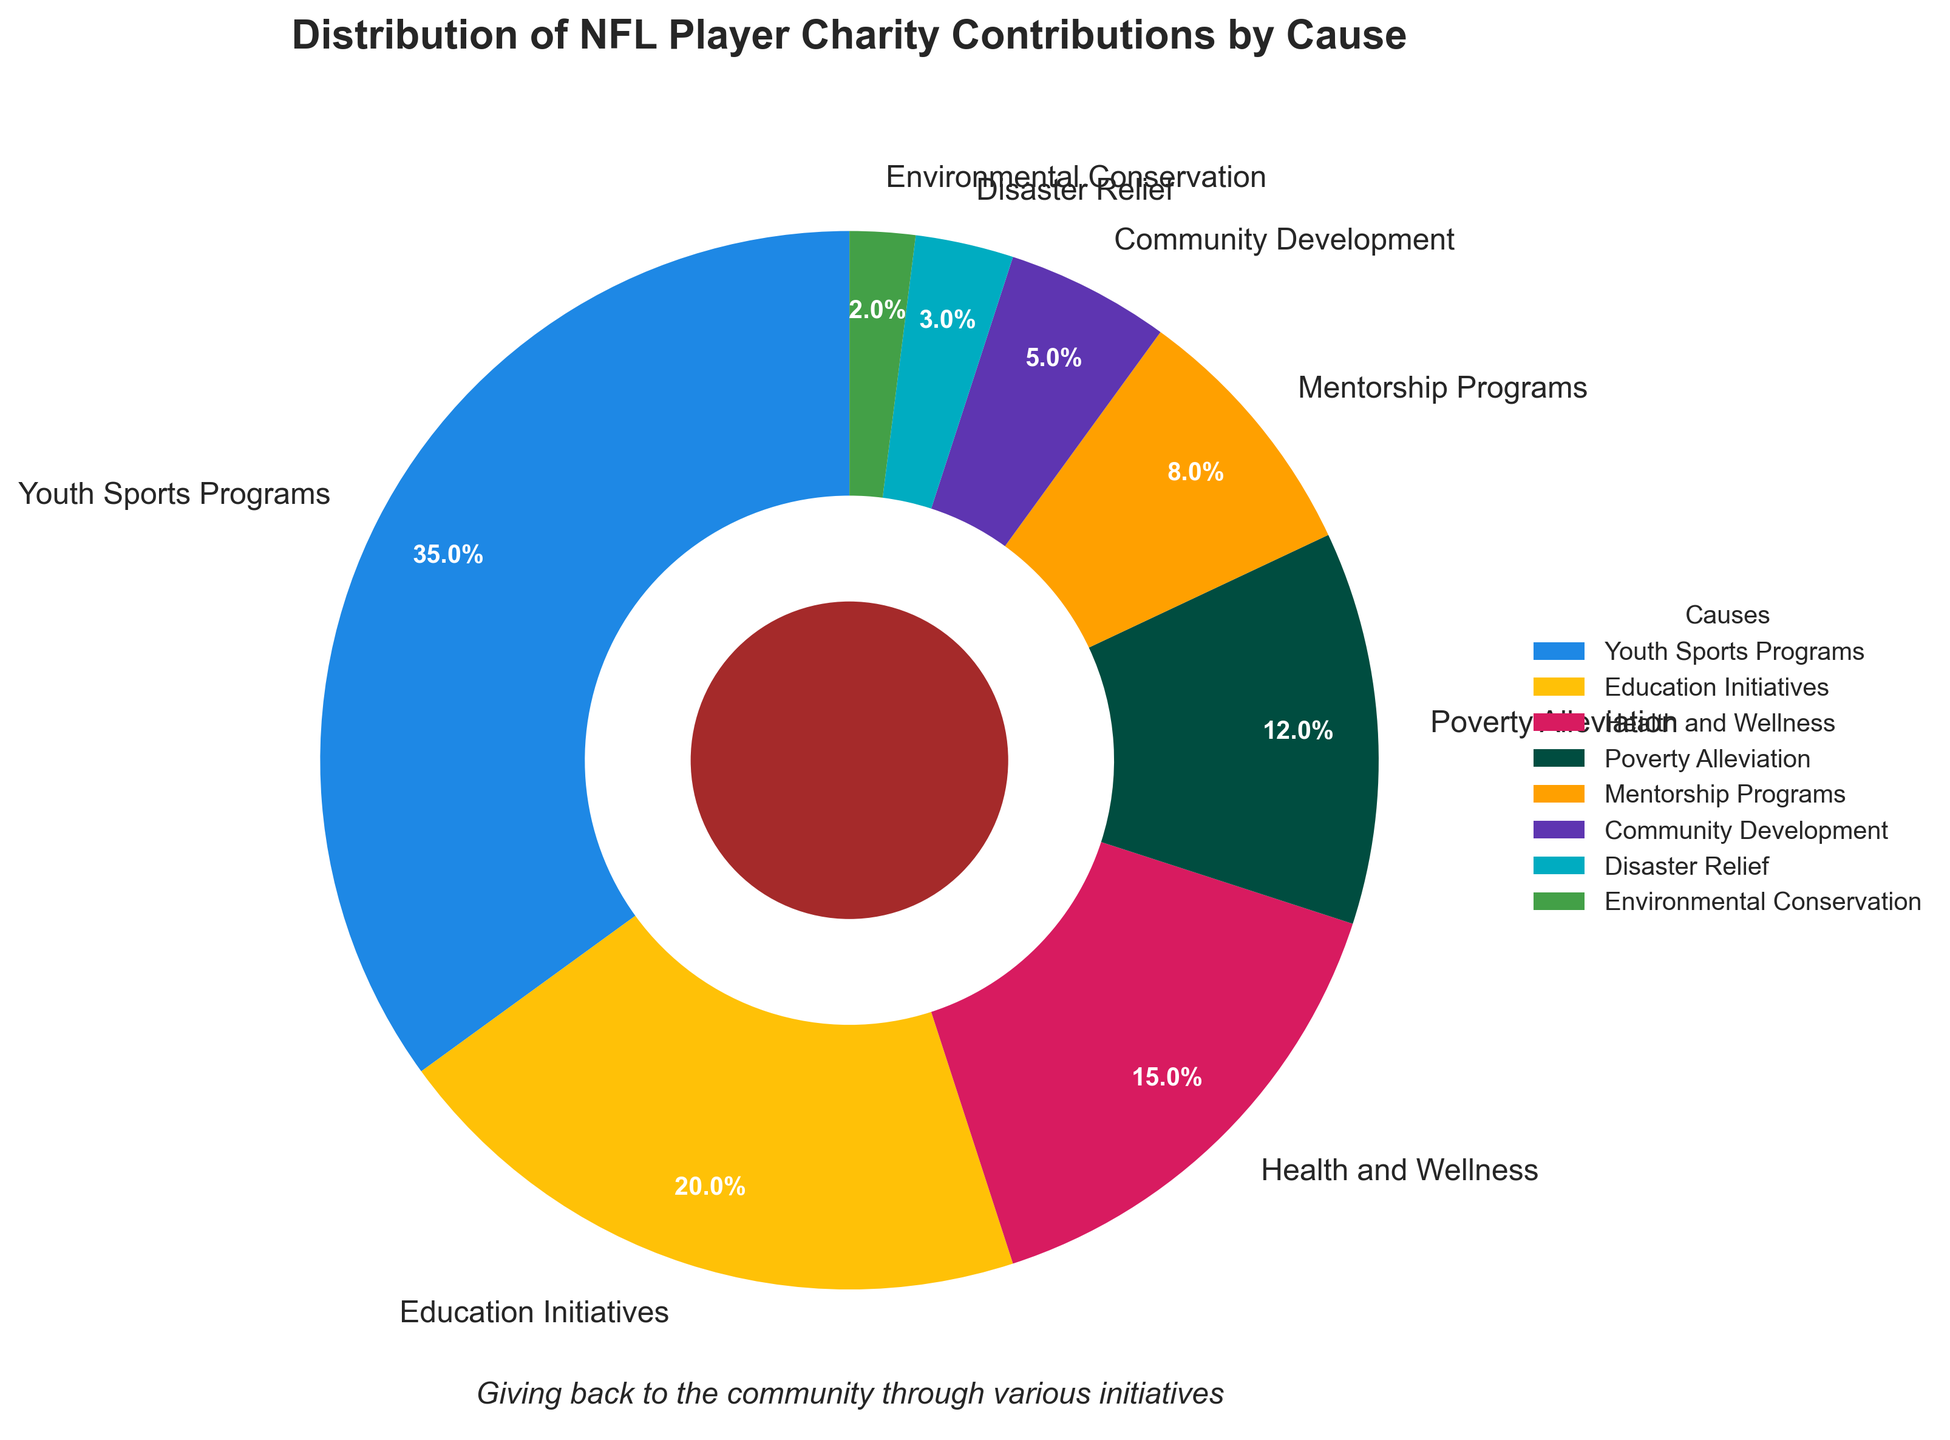What is the highest percentage cause receiving contributions? The highest percentage cause can be identified by looking at the slice of the pie chart with the largest area or by comparing the values next to each cause. Youth Sports Programs have the highest value at 35%.
Answer: Youth Sports Programs What is the combined percentage of contributions to Education Initiatives and Health and Wellness? To find this, add the percentages for Education Initiatives and Health and Wellness. Education Initiatives is 20%, and Health and Wellness is 15%, so the combined percentage is 20% + 15% = 35%.
Answer: 35% Which cause has the lowest percentage of contributions, and what is its percentage? Look for the slice of the pie chart with the smallest area or compare the values next to each cause. Environmental Conservation has the lowest percentage of 2%.
Answer: Environmental Conservation, 2% How much percentage more do Youth Sports Programs receive compared to Poverty Alleviation? Subtract the percentage of Poverty Alleviation from Youth Sports Programs. Youth Sports Programs are at 35%, and Poverty Alleviation is at 12%, so 35% - 12% = 23%.
Answer: 23% What is the difference in percentage between contributions to Community Development and Mentorship Programs? Subtract the percentage of Community Development from Mentorship Programs. Mentorship Programs have 8%, and Community Development has 5%, so 8% - 5% = 3%.
Answer: 3% Which causes receive an equal or lower percentage of contributions than 10%? Look for causes with percentages of 10% or below. Mentorship Programs (8%), Community Development (5%), Disaster Relief (3%), and Environmental Conservation (2%) qualify.
Answer: Mentorship Programs, Community Development, Disaster Relief, Environmental Conservation How many causes receive more than 10% of contributions? Count the segments with percentages greater than 10%. There are four such causes: Youth Sports Programs (35%), Education Initiatives (20%), Health and Wellness (15%), and Poverty Alleviation (12%).
Answer: 4 Is the fraction of contributions to Disaster Relief higher or lower than that to Community Development? Compare the percentage values for Disaster Relief and Community Development. Disaster Relief has 3%, while Community Development has 5%, so Disaster Relief is lower.
Answer: Lower 